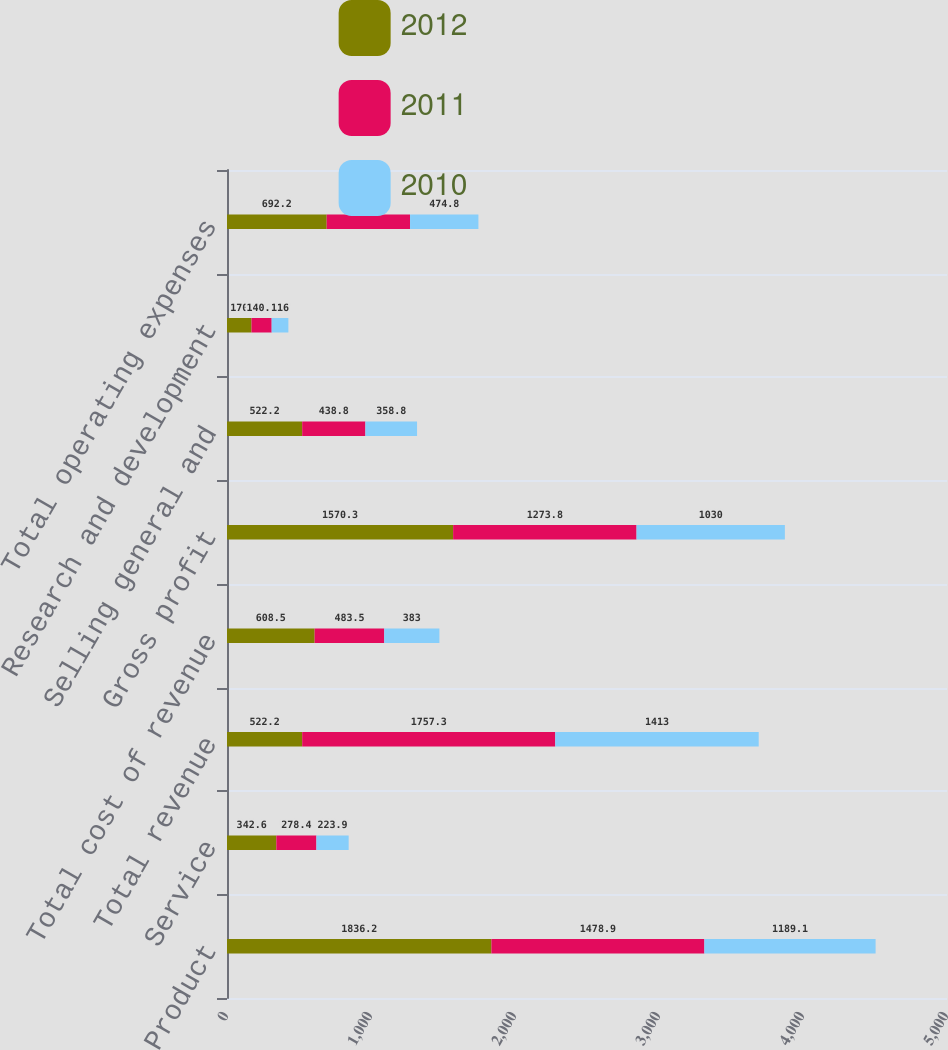Convert chart. <chart><loc_0><loc_0><loc_500><loc_500><stacked_bar_chart><ecel><fcel>Product<fcel>Service<fcel>Total revenue<fcel>Total cost of revenue<fcel>Gross profit<fcel>Selling general and<fcel>Research and development<fcel>Total operating expenses<nl><fcel>2012<fcel>1836.2<fcel>342.6<fcel>522.2<fcel>608.5<fcel>1570.3<fcel>522.2<fcel>170<fcel>692.2<nl><fcel>2011<fcel>1478.9<fcel>278.4<fcel>1757.3<fcel>483.5<fcel>1273.8<fcel>438.8<fcel>140.2<fcel>579<nl><fcel>2010<fcel>1189.1<fcel>223.9<fcel>1413<fcel>383<fcel>1030<fcel>358.8<fcel>116<fcel>474.8<nl></chart> 